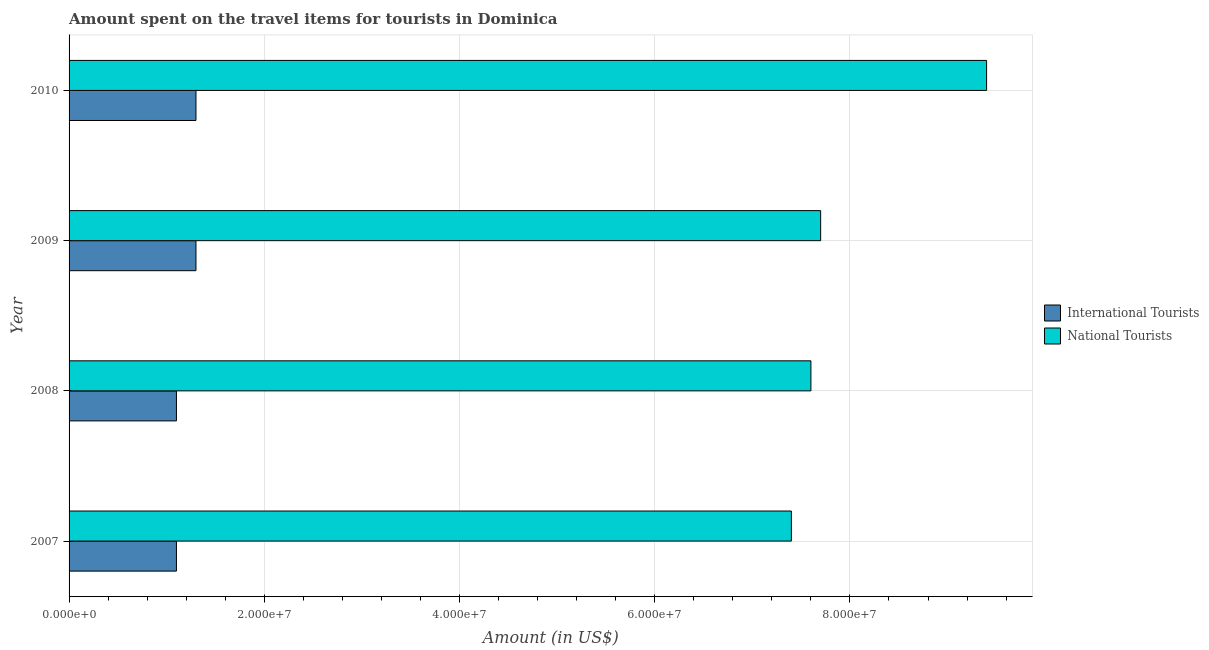How many different coloured bars are there?
Your response must be concise. 2. How many groups of bars are there?
Make the answer very short. 4. Are the number of bars per tick equal to the number of legend labels?
Keep it short and to the point. Yes. How many bars are there on the 3rd tick from the top?
Offer a very short reply. 2. How many bars are there on the 1st tick from the bottom?
Offer a very short reply. 2. In how many cases, is the number of bars for a given year not equal to the number of legend labels?
Your answer should be compact. 0. What is the amount spent on travel items of national tourists in 2009?
Ensure brevity in your answer.  7.70e+07. Across all years, what is the maximum amount spent on travel items of international tourists?
Offer a very short reply. 1.30e+07. Across all years, what is the minimum amount spent on travel items of national tourists?
Provide a succinct answer. 7.40e+07. In which year was the amount spent on travel items of international tourists minimum?
Provide a short and direct response. 2007. What is the total amount spent on travel items of national tourists in the graph?
Keep it short and to the point. 3.21e+08. What is the difference between the amount spent on travel items of international tourists in 2007 and that in 2009?
Provide a short and direct response. -2.00e+06. What is the difference between the amount spent on travel items of international tourists in 2009 and the amount spent on travel items of national tourists in 2007?
Your response must be concise. -6.10e+07. What is the average amount spent on travel items of national tourists per year?
Offer a terse response. 8.02e+07. In the year 2008, what is the difference between the amount spent on travel items of national tourists and amount spent on travel items of international tourists?
Give a very brief answer. 6.50e+07. What is the ratio of the amount spent on travel items of international tourists in 2009 to that in 2010?
Offer a very short reply. 1. Is the amount spent on travel items of international tourists in 2007 less than that in 2008?
Your response must be concise. No. What is the difference between the highest and the second highest amount spent on travel items of national tourists?
Offer a very short reply. 1.70e+07. What is the difference between the highest and the lowest amount spent on travel items of national tourists?
Your response must be concise. 2.00e+07. In how many years, is the amount spent on travel items of national tourists greater than the average amount spent on travel items of national tourists taken over all years?
Keep it short and to the point. 1. What does the 1st bar from the top in 2008 represents?
Give a very brief answer. National Tourists. What does the 2nd bar from the bottom in 2009 represents?
Offer a terse response. National Tourists. How many bars are there?
Offer a very short reply. 8. Are all the bars in the graph horizontal?
Give a very brief answer. Yes. How many years are there in the graph?
Give a very brief answer. 4. What is the difference between two consecutive major ticks on the X-axis?
Ensure brevity in your answer.  2.00e+07. Does the graph contain any zero values?
Make the answer very short. No. Where does the legend appear in the graph?
Offer a terse response. Center right. What is the title of the graph?
Keep it short and to the point. Amount spent on the travel items for tourists in Dominica. Does "Under-five" appear as one of the legend labels in the graph?
Your answer should be compact. No. What is the label or title of the X-axis?
Keep it short and to the point. Amount (in US$). What is the label or title of the Y-axis?
Your response must be concise. Year. What is the Amount (in US$) of International Tourists in 2007?
Your answer should be very brief. 1.10e+07. What is the Amount (in US$) of National Tourists in 2007?
Your response must be concise. 7.40e+07. What is the Amount (in US$) in International Tourists in 2008?
Provide a short and direct response. 1.10e+07. What is the Amount (in US$) in National Tourists in 2008?
Your answer should be compact. 7.60e+07. What is the Amount (in US$) of International Tourists in 2009?
Provide a short and direct response. 1.30e+07. What is the Amount (in US$) in National Tourists in 2009?
Your answer should be very brief. 7.70e+07. What is the Amount (in US$) in International Tourists in 2010?
Offer a terse response. 1.30e+07. What is the Amount (in US$) in National Tourists in 2010?
Give a very brief answer. 9.40e+07. Across all years, what is the maximum Amount (in US$) of International Tourists?
Give a very brief answer. 1.30e+07. Across all years, what is the maximum Amount (in US$) in National Tourists?
Offer a terse response. 9.40e+07. Across all years, what is the minimum Amount (in US$) in International Tourists?
Your response must be concise. 1.10e+07. Across all years, what is the minimum Amount (in US$) in National Tourists?
Keep it short and to the point. 7.40e+07. What is the total Amount (in US$) in International Tourists in the graph?
Ensure brevity in your answer.  4.80e+07. What is the total Amount (in US$) in National Tourists in the graph?
Ensure brevity in your answer.  3.21e+08. What is the difference between the Amount (in US$) of International Tourists in 2007 and that in 2009?
Give a very brief answer. -2.00e+06. What is the difference between the Amount (in US$) in National Tourists in 2007 and that in 2009?
Your answer should be compact. -3.00e+06. What is the difference between the Amount (in US$) in International Tourists in 2007 and that in 2010?
Your answer should be very brief. -2.00e+06. What is the difference between the Amount (in US$) in National Tourists in 2007 and that in 2010?
Provide a succinct answer. -2.00e+07. What is the difference between the Amount (in US$) of International Tourists in 2008 and that in 2009?
Give a very brief answer. -2.00e+06. What is the difference between the Amount (in US$) in National Tourists in 2008 and that in 2009?
Your response must be concise. -1.00e+06. What is the difference between the Amount (in US$) in International Tourists in 2008 and that in 2010?
Your answer should be compact. -2.00e+06. What is the difference between the Amount (in US$) in National Tourists in 2008 and that in 2010?
Give a very brief answer. -1.80e+07. What is the difference between the Amount (in US$) of National Tourists in 2009 and that in 2010?
Give a very brief answer. -1.70e+07. What is the difference between the Amount (in US$) of International Tourists in 2007 and the Amount (in US$) of National Tourists in 2008?
Keep it short and to the point. -6.50e+07. What is the difference between the Amount (in US$) in International Tourists in 2007 and the Amount (in US$) in National Tourists in 2009?
Your response must be concise. -6.60e+07. What is the difference between the Amount (in US$) in International Tourists in 2007 and the Amount (in US$) in National Tourists in 2010?
Your answer should be compact. -8.30e+07. What is the difference between the Amount (in US$) in International Tourists in 2008 and the Amount (in US$) in National Tourists in 2009?
Your answer should be compact. -6.60e+07. What is the difference between the Amount (in US$) of International Tourists in 2008 and the Amount (in US$) of National Tourists in 2010?
Offer a very short reply. -8.30e+07. What is the difference between the Amount (in US$) in International Tourists in 2009 and the Amount (in US$) in National Tourists in 2010?
Offer a very short reply. -8.10e+07. What is the average Amount (in US$) in International Tourists per year?
Your response must be concise. 1.20e+07. What is the average Amount (in US$) of National Tourists per year?
Your answer should be very brief. 8.02e+07. In the year 2007, what is the difference between the Amount (in US$) in International Tourists and Amount (in US$) in National Tourists?
Offer a very short reply. -6.30e+07. In the year 2008, what is the difference between the Amount (in US$) of International Tourists and Amount (in US$) of National Tourists?
Make the answer very short. -6.50e+07. In the year 2009, what is the difference between the Amount (in US$) of International Tourists and Amount (in US$) of National Tourists?
Your response must be concise. -6.40e+07. In the year 2010, what is the difference between the Amount (in US$) of International Tourists and Amount (in US$) of National Tourists?
Offer a very short reply. -8.10e+07. What is the ratio of the Amount (in US$) in National Tourists in 2007 to that in 2008?
Offer a very short reply. 0.97. What is the ratio of the Amount (in US$) of International Tourists in 2007 to that in 2009?
Provide a short and direct response. 0.85. What is the ratio of the Amount (in US$) of National Tourists in 2007 to that in 2009?
Ensure brevity in your answer.  0.96. What is the ratio of the Amount (in US$) of International Tourists in 2007 to that in 2010?
Ensure brevity in your answer.  0.85. What is the ratio of the Amount (in US$) of National Tourists in 2007 to that in 2010?
Ensure brevity in your answer.  0.79. What is the ratio of the Amount (in US$) in International Tourists in 2008 to that in 2009?
Your answer should be compact. 0.85. What is the ratio of the Amount (in US$) in International Tourists in 2008 to that in 2010?
Provide a succinct answer. 0.85. What is the ratio of the Amount (in US$) in National Tourists in 2008 to that in 2010?
Your answer should be very brief. 0.81. What is the ratio of the Amount (in US$) in International Tourists in 2009 to that in 2010?
Keep it short and to the point. 1. What is the ratio of the Amount (in US$) of National Tourists in 2009 to that in 2010?
Make the answer very short. 0.82. What is the difference between the highest and the second highest Amount (in US$) in National Tourists?
Provide a short and direct response. 1.70e+07. 